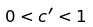Convert formula to latex. <formula><loc_0><loc_0><loc_500><loc_500>0 < c ^ { \prime } < 1</formula> 